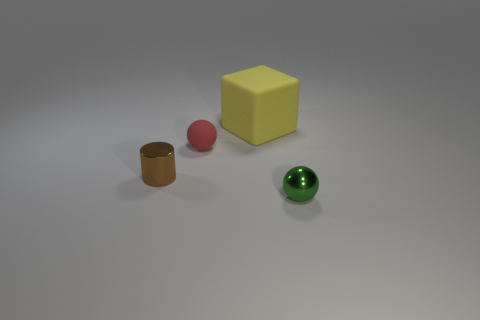What is the material of the object in front of the small shiny object behind the tiny object that is on the right side of the small red thing?
Provide a succinct answer. Metal. What is the color of the cylinder that is the same size as the rubber sphere?
Provide a short and direct response. Brown. What is the color of the tiny ball that is to the left of the small shiny object that is right of the red matte object?
Offer a terse response. Red. What is the shape of the metal thing that is in front of the shiny object that is on the left side of the small ball that is on the left side of the tiny green shiny object?
Provide a short and direct response. Sphere. There is a red rubber object behind the brown metallic cylinder; how many yellow blocks are to the right of it?
Offer a terse response. 1. Is the material of the big block the same as the small red thing?
Your answer should be compact. Yes. There is a tiny thing that is behind the small metallic thing that is to the left of the red object; what number of brown cylinders are on the left side of it?
Give a very brief answer. 1. There is a ball to the left of the metal sphere; what color is it?
Give a very brief answer. Red. What is the shape of the metallic object behind the shiny object that is in front of the tiny cylinder?
Provide a short and direct response. Cylinder. What number of cubes are either tiny red objects or yellow rubber things?
Ensure brevity in your answer.  1. 